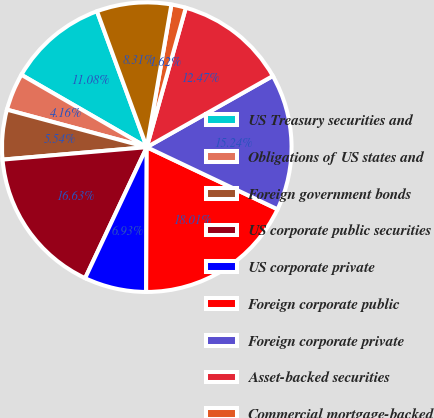<chart> <loc_0><loc_0><loc_500><loc_500><pie_chart><fcel>US Treasury securities and<fcel>Obligations of US states and<fcel>Foreign government bonds<fcel>US corporate public securities<fcel>US corporate private<fcel>Foreign corporate public<fcel>Foreign corporate private<fcel>Asset-backed securities<fcel>Commercial mortgage-backed<fcel>Residential mortgage-backed<nl><fcel>11.08%<fcel>4.16%<fcel>5.54%<fcel>16.63%<fcel>6.93%<fcel>18.01%<fcel>15.24%<fcel>12.47%<fcel>1.62%<fcel>8.31%<nl></chart> 